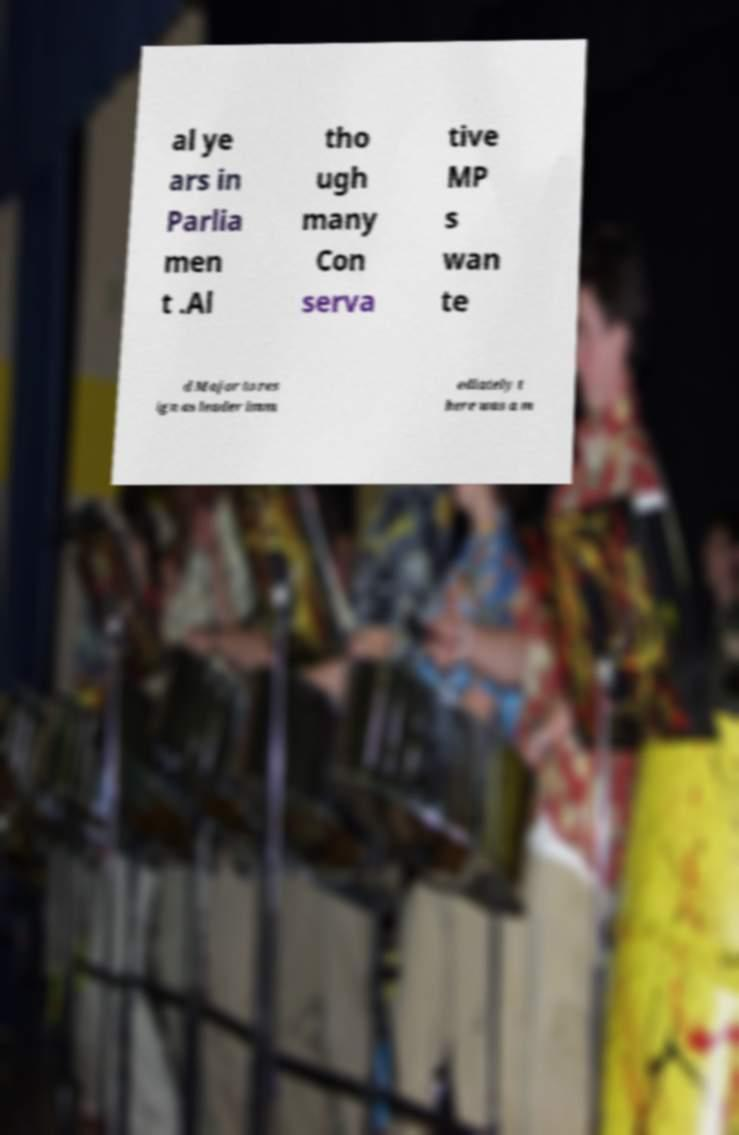Could you extract and type out the text from this image? al ye ars in Parlia men t .Al tho ugh many Con serva tive MP s wan te d Major to res ign as leader imm ediately t here was a m 